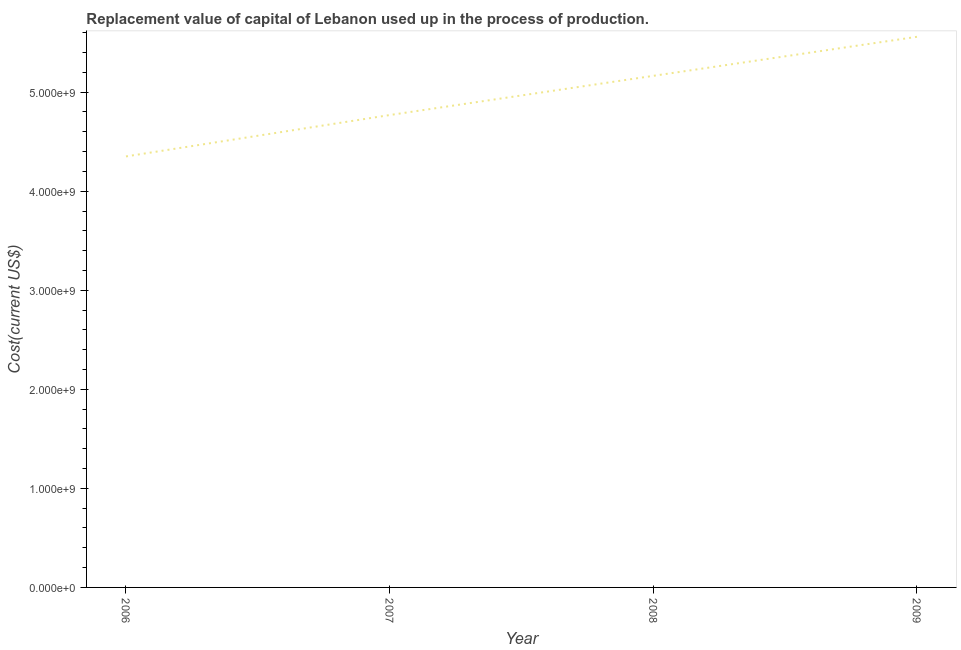What is the consumption of fixed capital in 2009?
Give a very brief answer. 5.56e+09. Across all years, what is the maximum consumption of fixed capital?
Give a very brief answer. 5.56e+09. Across all years, what is the minimum consumption of fixed capital?
Provide a succinct answer. 4.35e+09. In which year was the consumption of fixed capital maximum?
Provide a succinct answer. 2009. What is the sum of the consumption of fixed capital?
Your response must be concise. 1.98e+1. What is the difference between the consumption of fixed capital in 2006 and 2008?
Offer a very short reply. -8.14e+08. What is the average consumption of fixed capital per year?
Offer a very short reply. 4.96e+09. What is the median consumption of fixed capital?
Provide a short and direct response. 4.97e+09. In how many years, is the consumption of fixed capital greater than 5400000000 US$?
Your answer should be very brief. 1. What is the ratio of the consumption of fixed capital in 2008 to that in 2009?
Your answer should be very brief. 0.93. Is the consumption of fixed capital in 2006 less than that in 2008?
Ensure brevity in your answer.  Yes. Is the difference between the consumption of fixed capital in 2007 and 2009 greater than the difference between any two years?
Offer a terse response. No. What is the difference between the highest and the second highest consumption of fixed capital?
Your answer should be compact. 3.94e+08. What is the difference between the highest and the lowest consumption of fixed capital?
Ensure brevity in your answer.  1.21e+09. In how many years, is the consumption of fixed capital greater than the average consumption of fixed capital taken over all years?
Make the answer very short. 2. Does the consumption of fixed capital monotonically increase over the years?
Provide a short and direct response. Yes. How many years are there in the graph?
Give a very brief answer. 4. What is the difference between two consecutive major ticks on the Y-axis?
Make the answer very short. 1.00e+09. Does the graph contain any zero values?
Ensure brevity in your answer.  No. What is the title of the graph?
Ensure brevity in your answer.  Replacement value of capital of Lebanon used up in the process of production. What is the label or title of the X-axis?
Your answer should be very brief. Year. What is the label or title of the Y-axis?
Keep it short and to the point. Cost(current US$). What is the Cost(current US$) of 2006?
Provide a short and direct response. 4.35e+09. What is the Cost(current US$) of 2007?
Give a very brief answer. 4.77e+09. What is the Cost(current US$) in 2008?
Ensure brevity in your answer.  5.17e+09. What is the Cost(current US$) in 2009?
Your answer should be very brief. 5.56e+09. What is the difference between the Cost(current US$) in 2006 and 2007?
Provide a succinct answer. -4.18e+08. What is the difference between the Cost(current US$) in 2006 and 2008?
Make the answer very short. -8.14e+08. What is the difference between the Cost(current US$) in 2006 and 2009?
Provide a short and direct response. -1.21e+09. What is the difference between the Cost(current US$) in 2007 and 2008?
Ensure brevity in your answer.  -3.96e+08. What is the difference between the Cost(current US$) in 2007 and 2009?
Keep it short and to the point. -7.90e+08. What is the difference between the Cost(current US$) in 2008 and 2009?
Make the answer very short. -3.94e+08. What is the ratio of the Cost(current US$) in 2006 to that in 2007?
Your answer should be very brief. 0.91. What is the ratio of the Cost(current US$) in 2006 to that in 2008?
Offer a very short reply. 0.84. What is the ratio of the Cost(current US$) in 2006 to that in 2009?
Your answer should be very brief. 0.78. What is the ratio of the Cost(current US$) in 2007 to that in 2008?
Make the answer very short. 0.92. What is the ratio of the Cost(current US$) in 2007 to that in 2009?
Offer a very short reply. 0.86. What is the ratio of the Cost(current US$) in 2008 to that in 2009?
Your response must be concise. 0.93. 